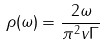<formula> <loc_0><loc_0><loc_500><loc_500>\rho ( \omega ) = \frac { 2 \omega } { \pi ^ { 2 } v \Gamma }</formula> 